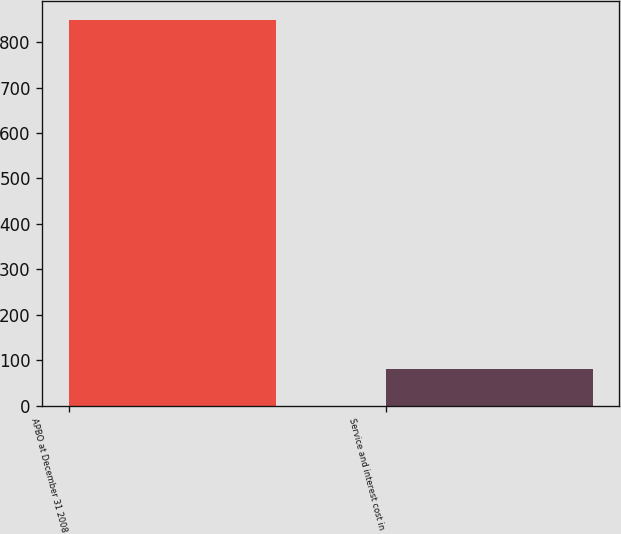Convert chart to OTSL. <chart><loc_0><loc_0><loc_500><loc_500><bar_chart><fcel>APBO at December 31 2008<fcel>Service and interest cost in<nl><fcel>848<fcel>80<nl></chart> 